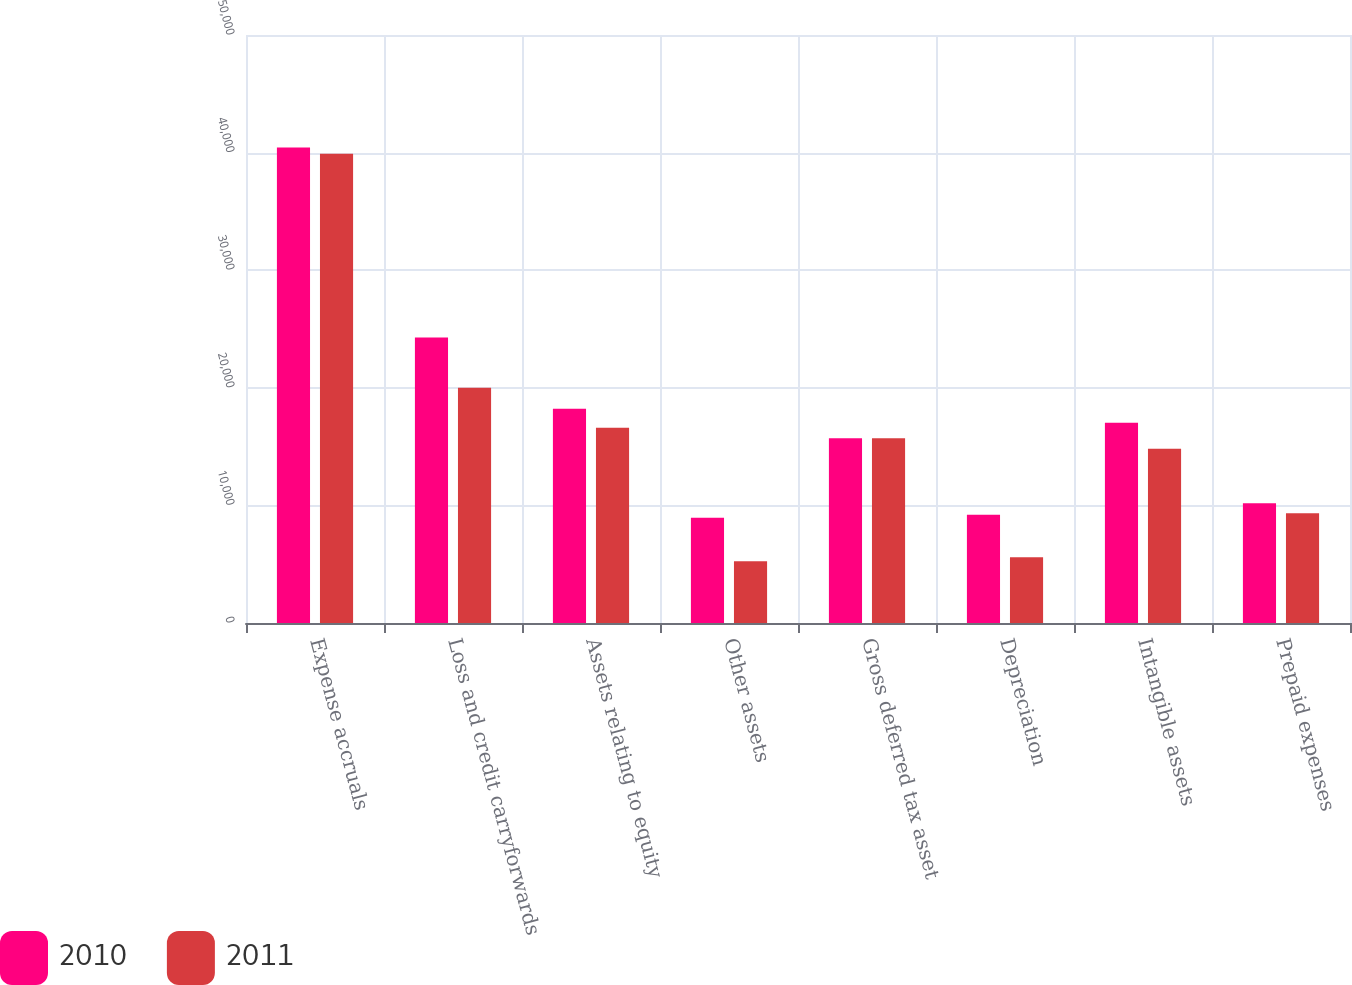Convert chart to OTSL. <chart><loc_0><loc_0><loc_500><loc_500><stacked_bar_chart><ecel><fcel>Expense accruals<fcel>Loss and credit carryforwards<fcel>Assets relating to equity<fcel>Other assets<fcel>Gross deferred tax asset<fcel>Depreciation<fcel>Intangible assets<fcel>Prepaid expenses<nl><fcel>2010<fcel>40438<fcel>24282<fcel>18226<fcel>8949<fcel>15707.5<fcel>9199<fcel>17024<fcel>10183<nl><fcel>2011<fcel>39892<fcel>19999<fcel>16599<fcel>5244<fcel>15707.5<fcel>5595<fcel>14816<fcel>9342<nl></chart> 